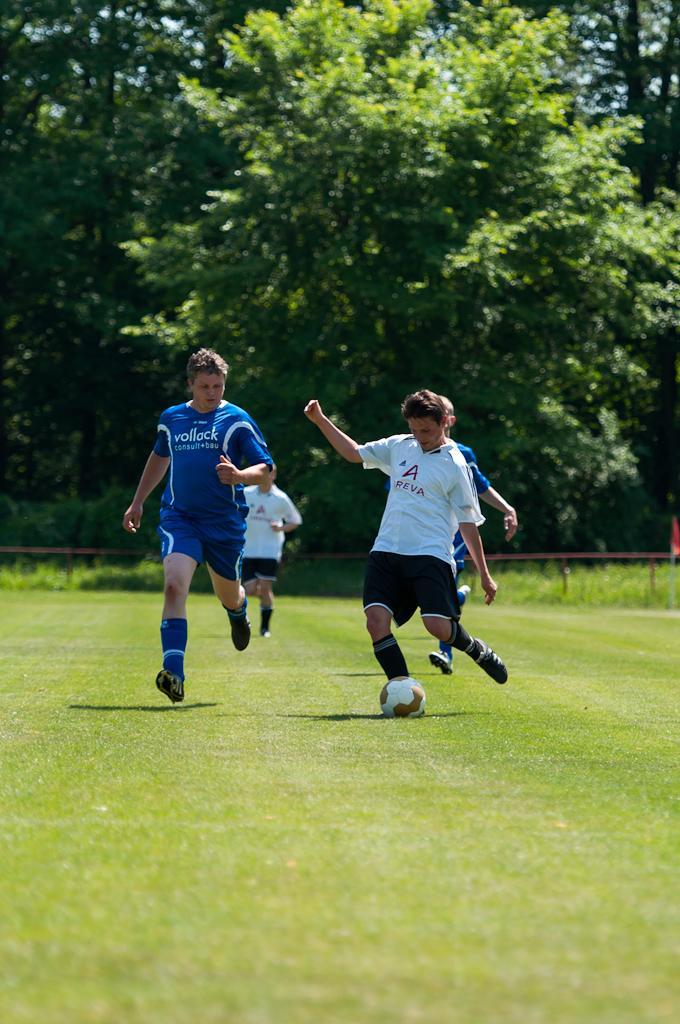Could you give a brief overview of what you see in this image? In this image there are group of persons running, another person kicking the ball in the ground. and the background there is tree, sky, iron rod, red color flag. 